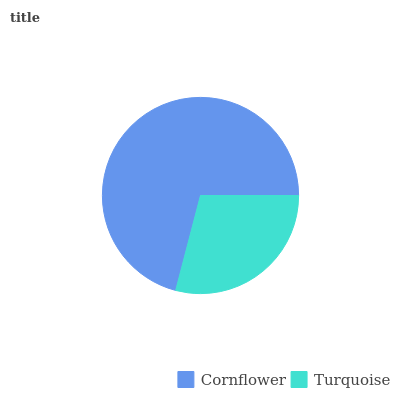Is Turquoise the minimum?
Answer yes or no. Yes. Is Cornflower the maximum?
Answer yes or no. Yes. Is Turquoise the maximum?
Answer yes or no. No. Is Cornflower greater than Turquoise?
Answer yes or no. Yes. Is Turquoise less than Cornflower?
Answer yes or no. Yes. Is Turquoise greater than Cornflower?
Answer yes or no. No. Is Cornflower less than Turquoise?
Answer yes or no. No. Is Cornflower the high median?
Answer yes or no. Yes. Is Turquoise the low median?
Answer yes or no. Yes. Is Turquoise the high median?
Answer yes or no. No. Is Cornflower the low median?
Answer yes or no. No. 